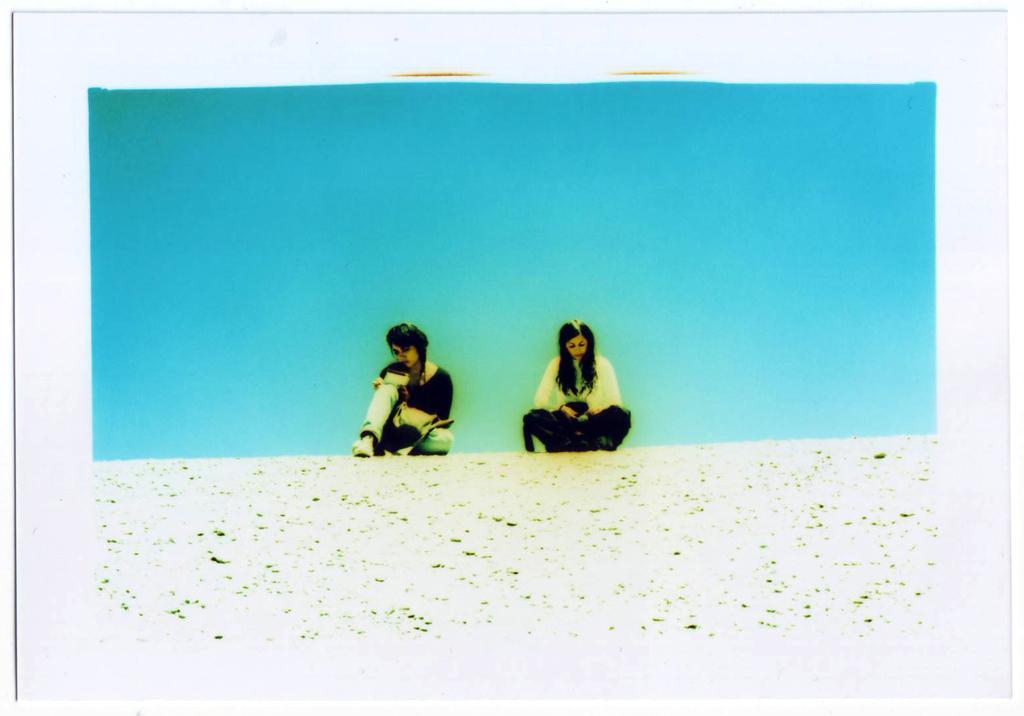In one or two sentences, can you explain what this image depicts? Middle of the image we can see two people. Background it is in blue color. 